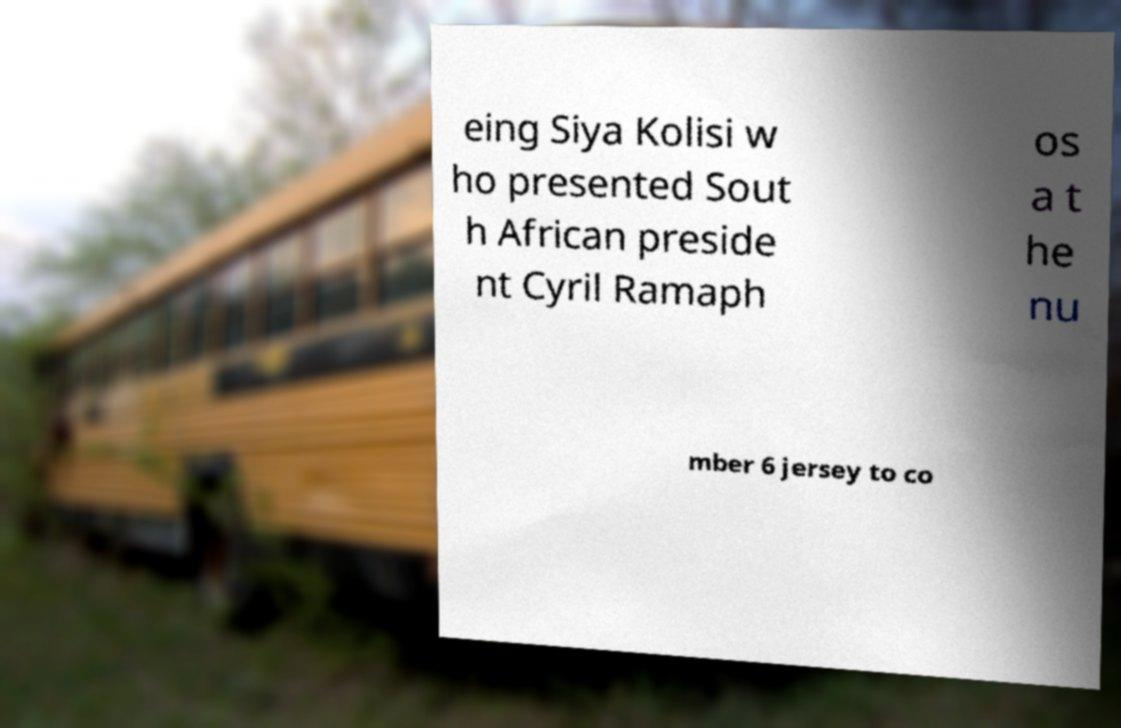Please read and relay the text visible in this image. What does it say? eing Siya Kolisi w ho presented Sout h African preside nt Cyril Ramaph os a t he nu mber 6 jersey to co 